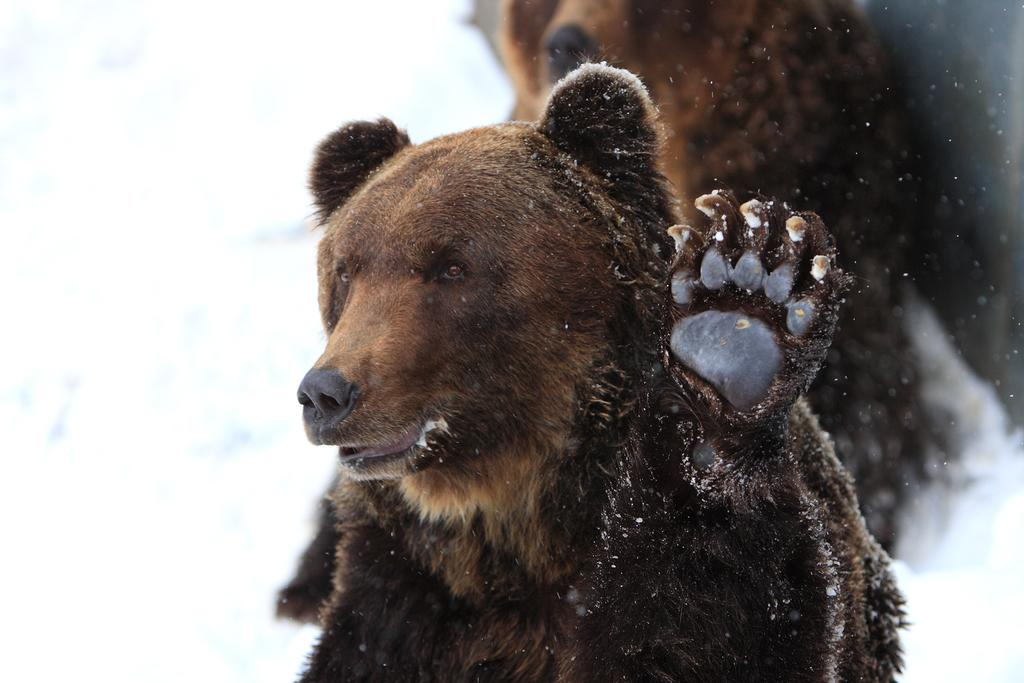What is the main subject in the center of the image? There is a bear in the center of the image. Can you describe the appearance of the bear? The bear is brown in color. Are there any other bears visible in the image? Yes, there is another bear in the background of the image. What route does the bear take to fulfill the request in the image? There is no request or route mentioned in the image; it simply shows two bears. 